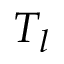<formula> <loc_0><loc_0><loc_500><loc_500>T _ { l }</formula> 